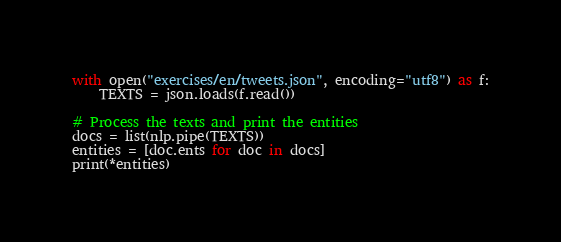Convert code to text. <code><loc_0><loc_0><loc_500><loc_500><_Python_>
with open("exercises/en/tweets.json", encoding="utf8") as f:
    TEXTS = json.loads(f.read())

# Process the texts and print the entities
docs = list(nlp.pipe(TEXTS))
entities = [doc.ents for doc in docs]
print(*entities)
</code> 